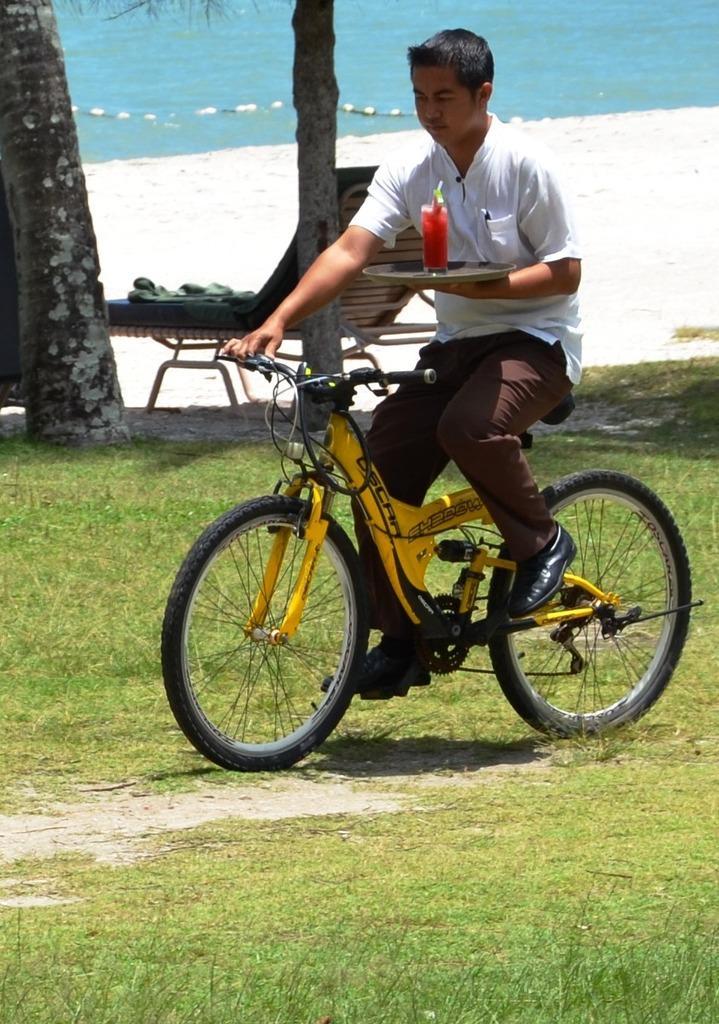In one or two sentences, can you explain what this image depicts? In the image we can see there is a man who is sitting on bicycle and the ground is covered with grass and a man is holding plate in which there is a juice glass. 